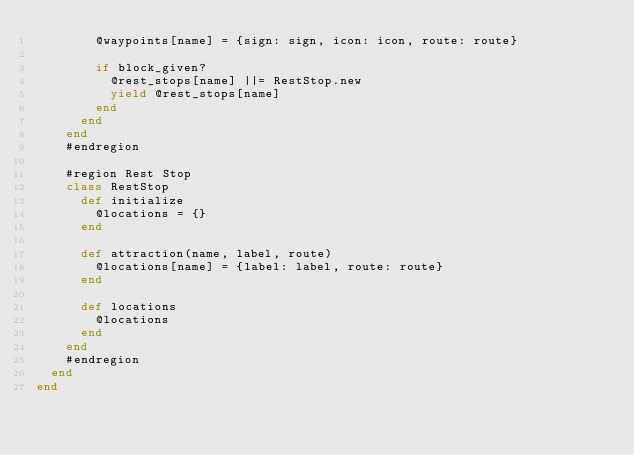<code> <loc_0><loc_0><loc_500><loc_500><_Ruby_>        @waypoints[name] = {sign: sign, icon: icon, route: route}

        if block_given?
          @rest_stops[name] ||= RestStop.new
          yield @rest_stops[name]
        end
      end
    end
    #endregion

    #region Rest Stop
    class RestStop
      def initialize
        @locations = {}
      end

      def attraction(name, label, route)
        @locations[name] = {label: label, route: route}
      end

      def locations
        @locations
      end
    end
    #endregion
  end
end</code> 